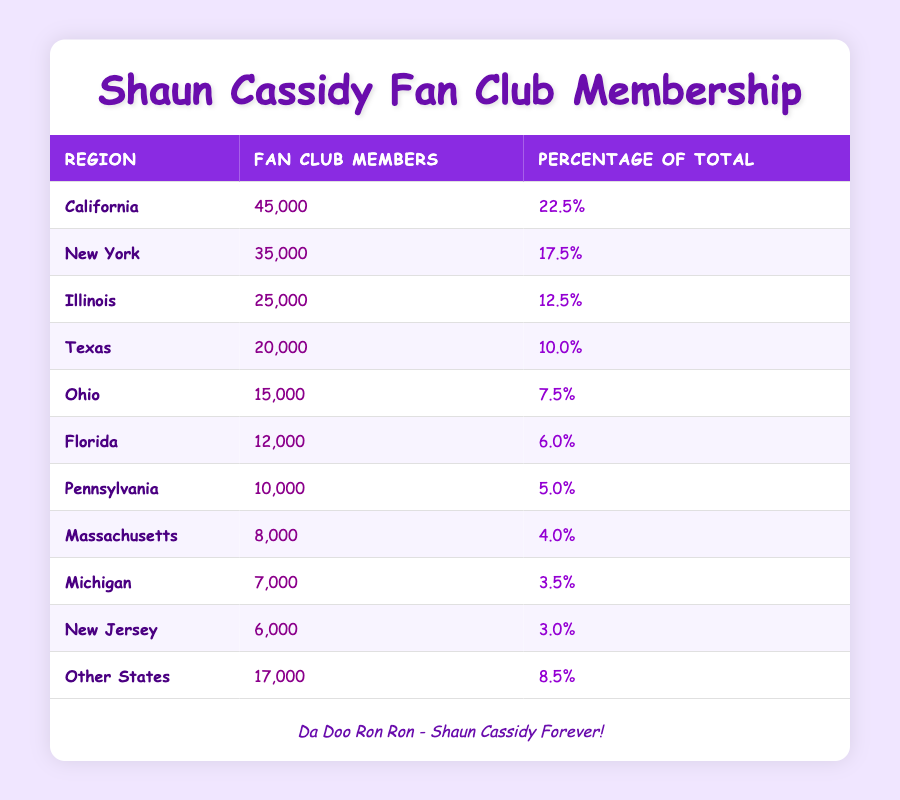What region has the highest number of fan club members? California has the highest number of fan club members with 45,000. The data is clearly listed in the table, and California's member count is higher than that of any other region.
Answer: California What percentage of total fan club members comes from Florida? Florida has 12,000 members, and the table indicates that this represents 6.0% of the total fan club membership across all regions listed.
Answer: 6.0% Is the number of fan club members from Texas greater than that from Ohio? Yes, Texas has 20,000 fan club members while Ohio only has 15,000, so Texas has a greater number of members than Ohio.
Answer: Yes What is the total number of fan club members in New York and Illinois combined? Adding the members from New York (35,000) and Illinois (25,000) gives a total of 60,000 (35,000 + 25,000 = 60,000).
Answer: 60,000 What region contributes the least to the total membership and what is that contribution? Massachusetts contributes the least to the total membership, with 8,000 members. This is the least number listed in the table, confirming it as the smallest value.
Answer: Massachusetts, 8,000 What is the average number of fan club members across the top three regions? The top three regions are California (45,000), New York (35,000), and Illinois (25,000). Adding these together gives 105,000. To find the average, divide by 3: 105,000 / 3 = 35,000.
Answer: 35,000 Is it true that the fans in "Other States" account for more than 10% of the total membership? Yes, "Other States" has 17,000 members, which is 8.5% of the total membership, but since it's less than 10%, the statement is false.
Answer: No How many more members does California have compared to New Jersey? California has 45,000 members and New Jersey has 6,000, so the difference is 45,000 - 6,000 = 39,000.
Answer: 39,000 What percentage of the total membership do the combined members from Florida, Pennsylvania, and Massachusetts represent? The combined membership is 12,000 (Florida) + 10,000 (Pennsylvania) + 8,000 (Massachusetts) = 30,000. The total number of members is 200,000, therefore the percentage is (30,000 / 200,000) * 100 = 15%.
Answer: 15% 